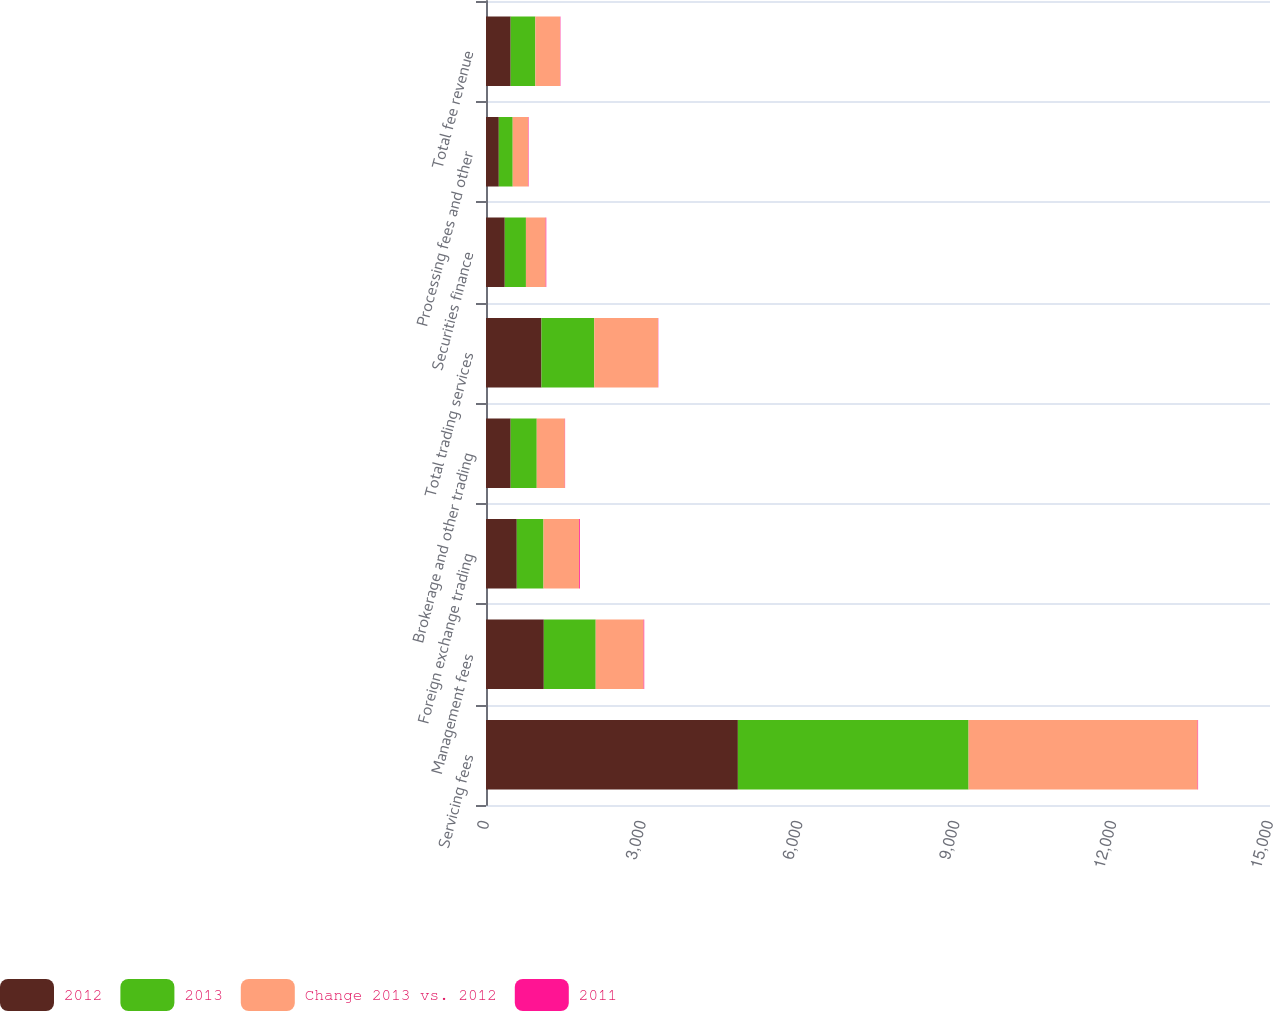<chart> <loc_0><loc_0><loc_500><loc_500><stacked_bar_chart><ecel><fcel>Servicing fees<fcel>Management fees<fcel>Foreign exchange trading<fcel>Brokerage and other trading<fcel>Total trading services<fcel>Securities finance<fcel>Processing fees and other<fcel>Total fee revenue<nl><fcel>2012<fcel>4819<fcel>1106<fcel>589<fcel>472<fcel>1061<fcel>359<fcel>245<fcel>472<nl><fcel>2013<fcel>4414<fcel>993<fcel>511<fcel>499<fcel>1010<fcel>405<fcel>266<fcel>472<nl><fcel>Change 2013 vs. 2012<fcel>4382<fcel>917<fcel>683<fcel>537<fcel>1220<fcel>378<fcel>297<fcel>472<nl><fcel>2011<fcel>9<fcel>11<fcel>15<fcel>5<fcel>5<fcel>11<fcel>8<fcel>7<nl></chart> 